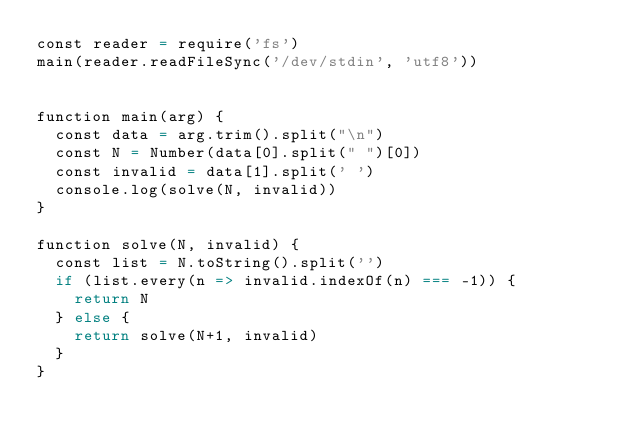Convert code to text. <code><loc_0><loc_0><loc_500><loc_500><_Scala_>const reader = require('fs')
main(reader.readFileSync('/dev/stdin', 'utf8'))


function main(arg) {
  const data = arg.trim().split("\n")
  const N = Number(data[0].split(" ")[0])
  const invalid = data[1].split(' ')
  console.log(solve(N, invalid))
}

function solve(N, invalid) {
  const list = N.toString().split('')
  if (list.every(n => invalid.indexOf(n) === -1)) {
    return N
  } else {
    return solve(N+1, invalid)
  }
}


</code> 